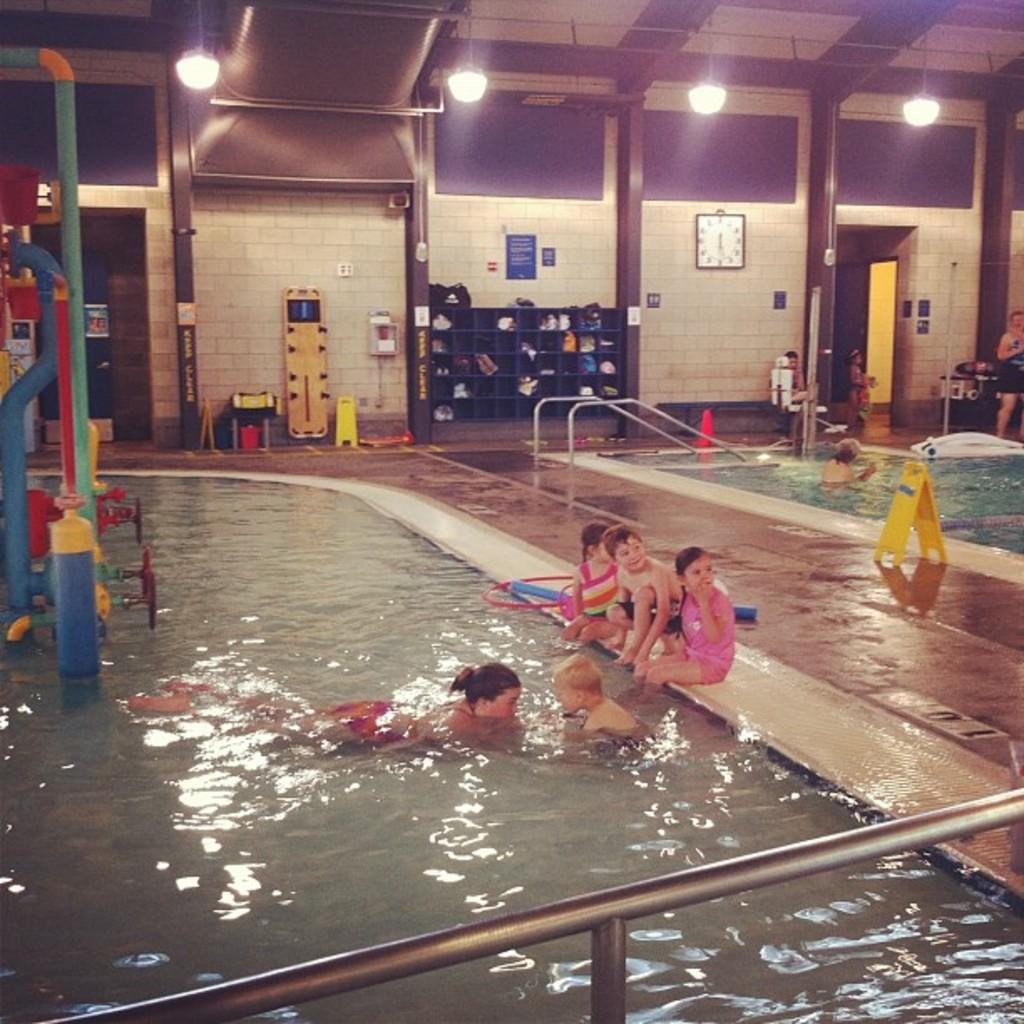How many people are present in the image? There are many people in the image. What activity is one of the people engaged in? A person is swimming in the image. What type of environment is depicted in the image? There is water visible in the image. What type of furniture is present in the image? There are cupboards in the image. What type of illumination is present in the image? There is a light in the image. What type of timekeeping device is present in the image? There is a clock in the image. What other objects can be seen in the image? There are other objects in the image. What type of infrastructure is present in the image? There is a road in the image. What type of frame is used to support the operation of the belief in the image? There is no mention of a frame, operation, or belief in the image; it primarily features people, water, cupboards, a light, a clock, other objects, and a road. 